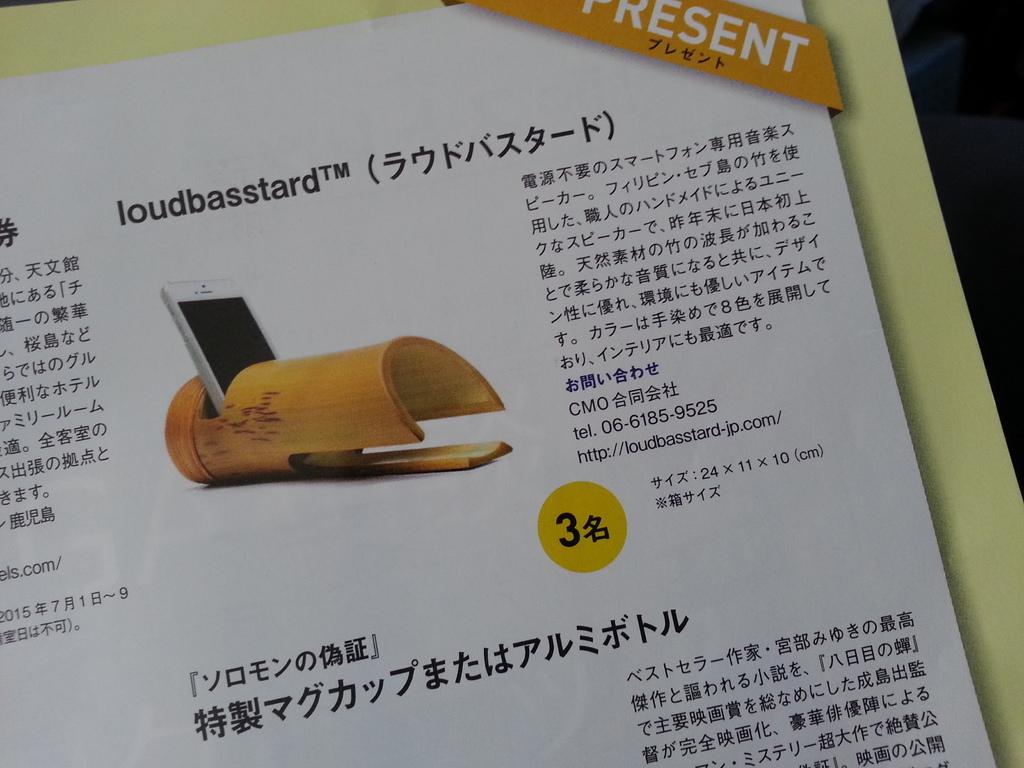What is the brand of this device?
Keep it short and to the point. Loudbasstard. What letter is written inside the yellow circle?
Provide a short and direct response. 3. 